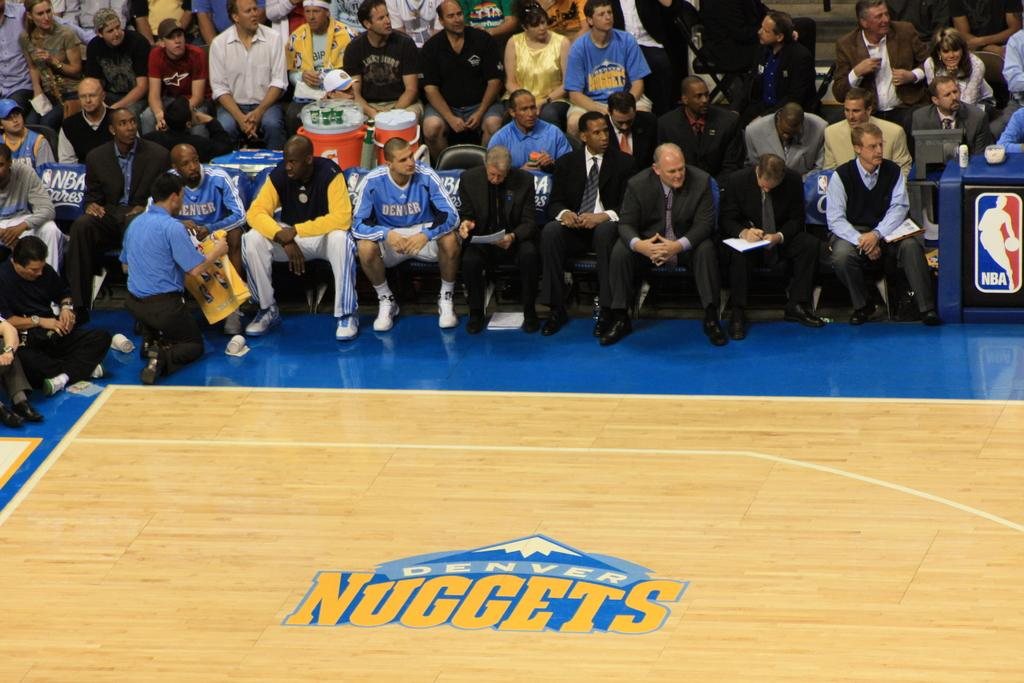What type of sports facility is shown in the image? There is a basketball court in the image. Can you describe the people in the image? There are people sitting on chairs at the top of the image. What else can be seen on the right side of the image? There are objects on a table on the right side of the image. What type of view can be seen from the volleyball court in the image? There is no volleyball court present in the image, and therefore no view from a volleyball court can be observed. How many children are playing on the basketball court in the image? There is no information about children playing on the basketball court in the image, and therefore we cannot determine the number of children present. 